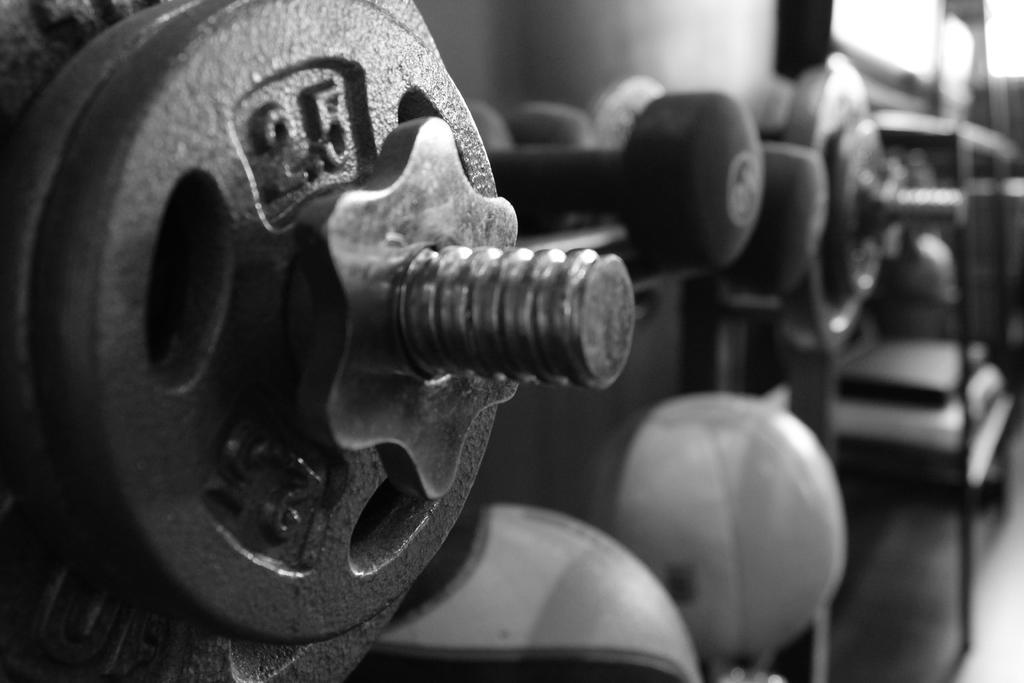In one or two sentences, can you explain what this image depicts? In this black and white picture there are dumbbells and weight plates. To the right there is a rack. At the bottom there are balls. Behind them there is a wall. 